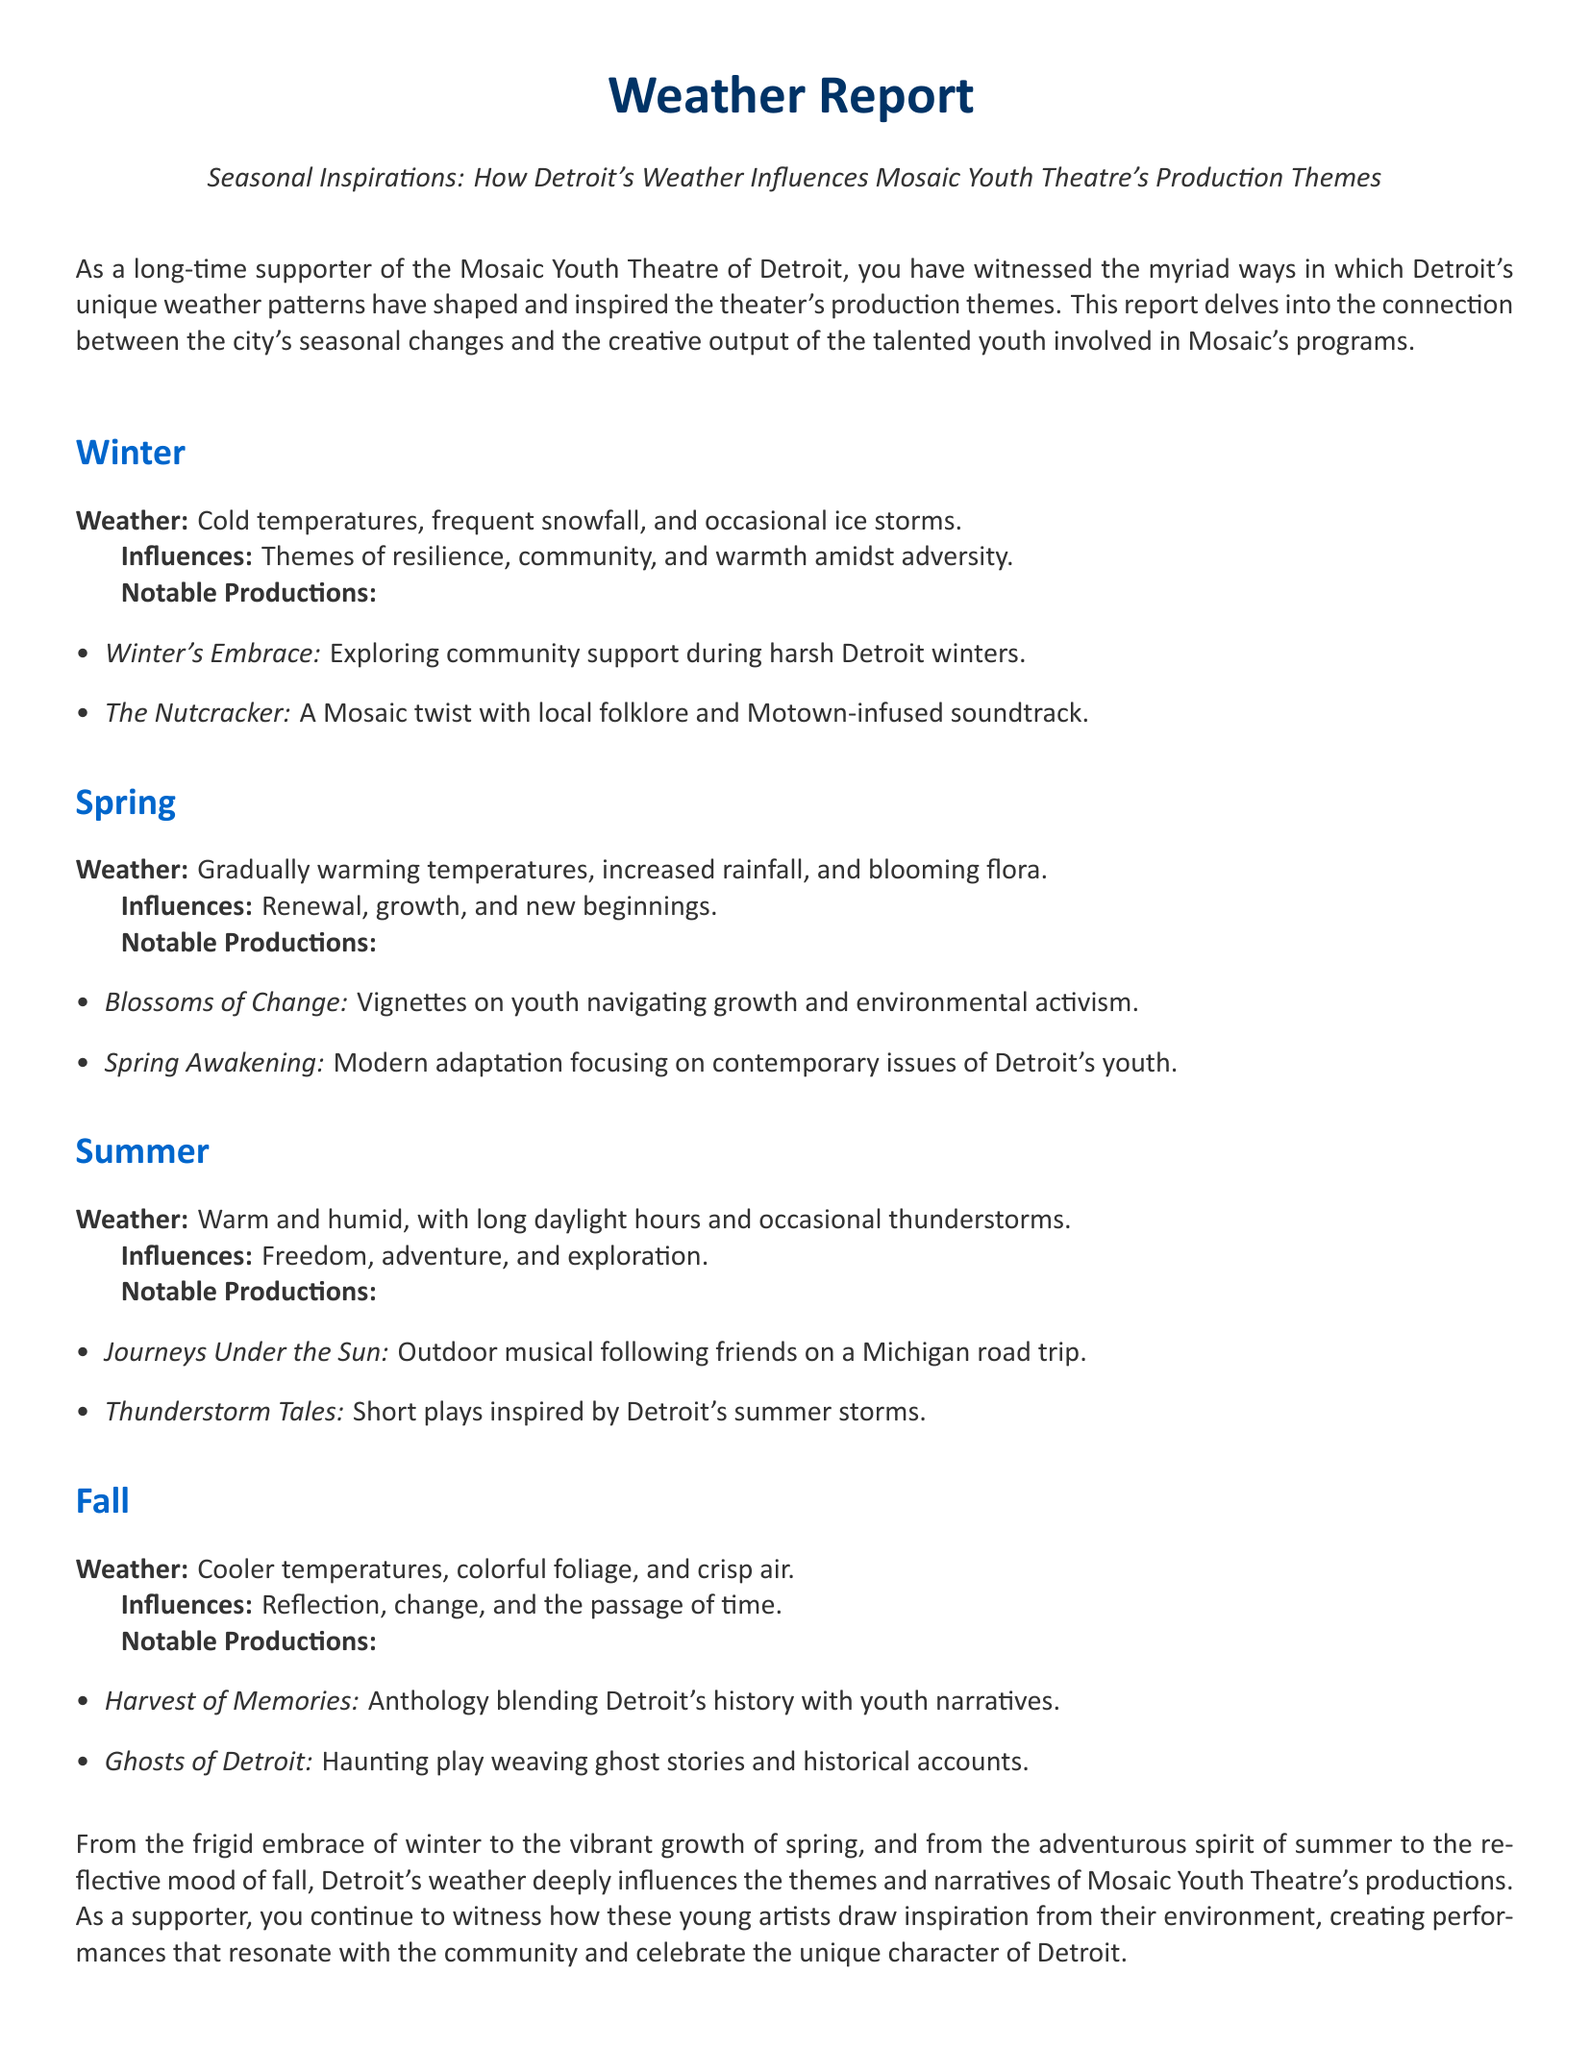What are the winter weather conditions in Detroit? The document describes winter weather conditions as cold temperatures, frequent snowfall, and occasional ice storms.
Answer: Cold temperatures, frequent snowfall, and occasional ice storms What theme is represented in the productions during spring? The spring section indicates that the influences are renewal, growth, and new beginnings.
Answer: Renewal, growth, and new beginnings What is the title of a summer production inspired by thunderstorms? The document lists "Thunderstorm Tales" as a notable summer production inspired by summer storms.
Answer: Thunderstorm Tales How does Detroit's fall weather influence themes? The fall section states that the influences are reflection, change, and the passage of time.
Answer: Reflection, change, and the passage of time Which production explores community support during winter? The document mentions "Winter's Embrace" as a production exploring community support during harsh Detroit winters.
Answer: Winter's Embrace What type of weather is associated with summer productions? The summer section describes the weather as warm and humid, with long daylight hours and occasional thunderstorms.
Answer: Warm and humid, with long daylight hours and occasional thunderstorms How many notable productions are mentioned for spring? The document lists two notable productions for spring, which are "Blossoms of Change" and "Spring Awakening."
Answer: Two What seasonal changes are reflected in the themes of Mosaic Youth Theatre? The document explains that Detroit's seasonal changes deeply influence the themes and narratives of the productions.
Answer: Seasonal changes 